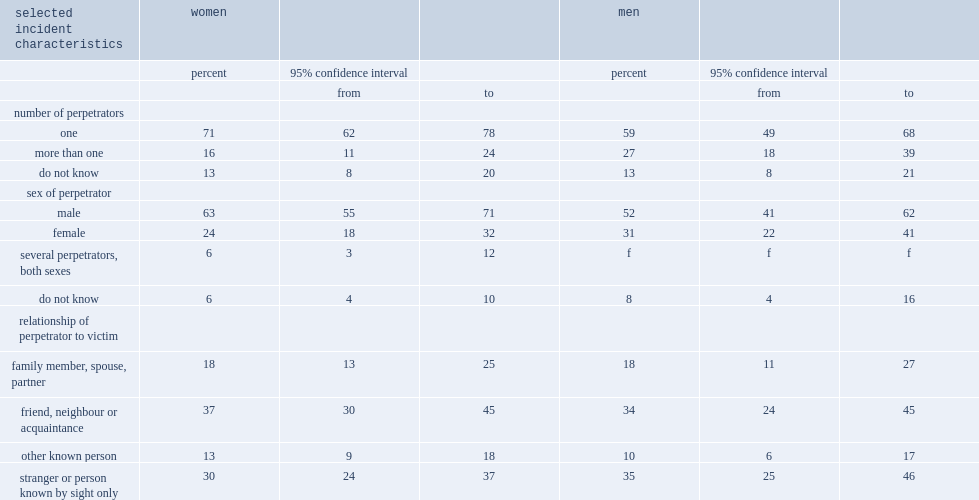What is the percentage of women who indicated that a single person was behind the unwanted behavior online? 71.0. What is the percentage of men who indicated that a single person was behind the unwanted behavior online? 59.0. What is the percentage of both men and women who had experienced at least on unwanted behavior online and who could not say how many people were responsible for the most serious incident? 13.0 13.0. What is the percentage of women who indicated that the perpetrator of unwanted behavior online was male? 63.0. 